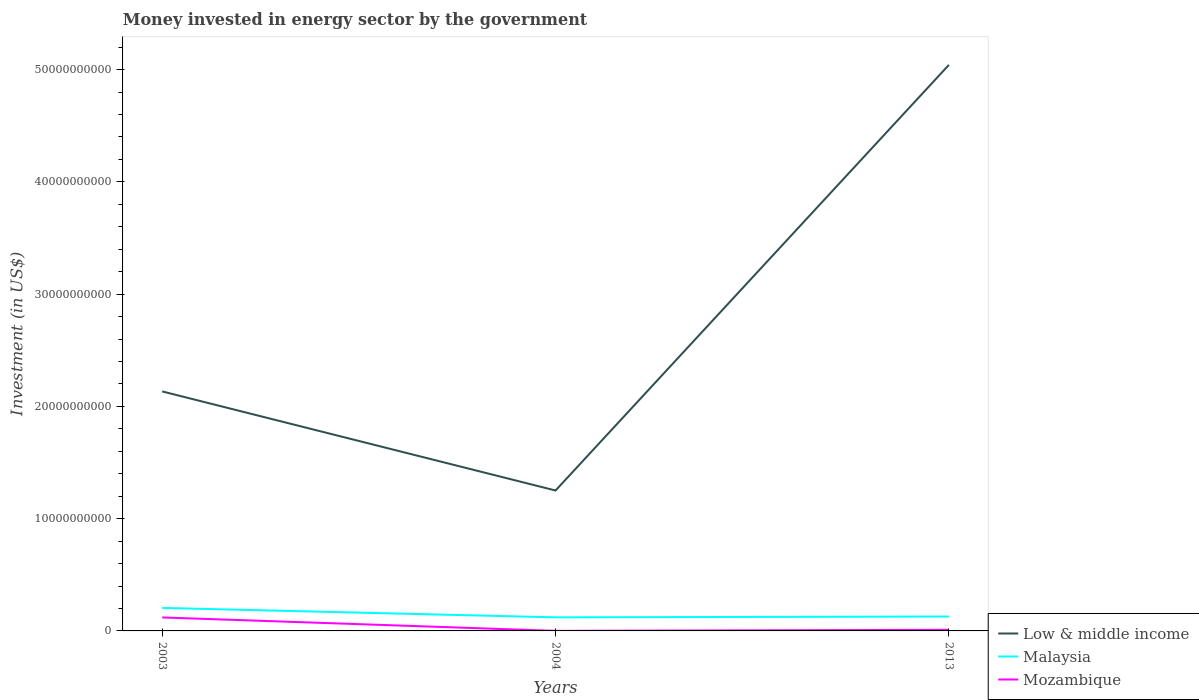How many different coloured lines are there?
Keep it short and to the point. 3. Does the line corresponding to Low & middle income intersect with the line corresponding to Malaysia?
Give a very brief answer. No. Across all years, what is the maximum money spent in energy sector in Malaysia?
Provide a short and direct response. 1.21e+09. In which year was the money spent in energy sector in Low & middle income maximum?
Offer a terse response. 2004. What is the total money spent in energy sector in Low & middle income in the graph?
Your answer should be very brief. -2.91e+1. What is the difference between the highest and the second highest money spent in energy sector in Mozambique?
Offer a terse response. 1.19e+09. How many years are there in the graph?
Keep it short and to the point. 3. Are the values on the major ticks of Y-axis written in scientific E-notation?
Make the answer very short. No. Does the graph contain any zero values?
Ensure brevity in your answer.  No. Does the graph contain grids?
Keep it short and to the point. No. How are the legend labels stacked?
Give a very brief answer. Vertical. What is the title of the graph?
Provide a short and direct response. Money invested in energy sector by the government. Does "Low income" appear as one of the legend labels in the graph?
Your response must be concise. No. What is the label or title of the X-axis?
Provide a short and direct response. Years. What is the label or title of the Y-axis?
Make the answer very short. Investment (in US$). What is the Investment (in US$) of Low & middle income in 2003?
Your answer should be compact. 2.13e+1. What is the Investment (in US$) in Malaysia in 2003?
Provide a succinct answer. 2.05e+09. What is the Investment (in US$) in Mozambique in 2003?
Ensure brevity in your answer.  1.20e+09. What is the Investment (in US$) of Low & middle income in 2004?
Give a very brief answer. 1.25e+1. What is the Investment (in US$) in Malaysia in 2004?
Provide a short and direct response. 1.21e+09. What is the Investment (in US$) in Mozambique in 2004?
Offer a very short reply. 5.80e+06. What is the Investment (in US$) in Low & middle income in 2013?
Your response must be concise. 5.04e+1. What is the Investment (in US$) of Malaysia in 2013?
Provide a short and direct response. 1.28e+09. What is the Investment (in US$) of Mozambique in 2013?
Provide a succinct answer. 9.87e+07. Across all years, what is the maximum Investment (in US$) in Low & middle income?
Provide a short and direct response. 5.04e+1. Across all years, what is the maximum Investment (in US$) in Malaysia?
Ensure brevity in your answer.  2.05e+09. Across all years, what is the maximum Investment (in US$) of Mozambique?
Give a very brief answer. 1.20e+09. Across all years, what is the minimum Investment (in US$) of Low & middle income?
Give a very brief answer. 1.25e+1. Across all years, what is the minimum Investment (in US$) of Malaysia?
Give a very brief answer. 1.21e+09. Across all years, what is the minimum Investment (in US$) in Mozambique?
Your response must be concise. 5.80e+06. What is the total Investment (in US$) of Low & middle income in the graph?
Offer a very short reply. 8.43e+1. What is the total Investment (in US$) of Malaysia in the graph?
Offer a very short reply. 4.54e+09. What is the total Investment (in US$) in Mozambique in the graph?
Ensure brevity in your answer.  1.30e+09. What is the difference between the Investment (in US$) in Low & middle income in 2003 and that in 2004?
Your response must be concise. 8.83e+09. What is the difference between the Investment (in US$) in Malaysia in 2003 and that in 2004?
Offer a very short reply. 8.40e+08. What is the difference between the Investment (in US$) in Mozambique in 2003 and that in 2004?
Give a very brief answer. 1.19e+09. What is the difference between the Investment (in US$) of Low & middle income in 2003 and that in 2013?
Your answer should be very brief. -2.91e+1. What is the difference between the Investment (in US$) in Malaysia in 2003 and that in 2013?
Provide a succinct answer. 7.67e+08. What is the difference between the Investment (in US$) in Mozambique in 2003 and that in 2013?
Provide a succinct answer. 1.10e+09. What is the difference between the Investment (in US$) of Low & middle income in 2004 and that in 2013?
Provide a succinct answer. -3.79e+1. What is the difference between the Investment (in US$) in Malaysia in 2004 and that in 2013?
Your response must be concise. -7.30e+07. What is the difference between the Investment (in US$) in Mozambique in 2004 and that in 2013?
Make the answer very short. -9.29e+07. What is the difference between the Investment (in US$) in Low & middle income in 2003 and the Investment (in US$) in Malaysia in 2004?
Provide a succinct answer. 2.01e+1. What is the difference between the Investment (in US$) of Low & middle income in 2003 and the Investment (in US$) of Mozambique in 2004?
Keep it short and to the point. 2.13e+1. What is the difference between the Investment (in US$) of Malaysia in 2003 and the Investment (in US$) of Mozambique in 2004?
Your answer should be very brief. 2.04e+09. What is the difference between the Investment (in US$) of Low & middle income in 2003 and the Investment (in US$) of Malaysia in 2013?
Provide a succinct answer. 2.01e+1. What is the difference between the Investment (in US$) in Low & middle income in 2003 and the Investment (in US$) in Mozambique in 2013?
Offer a terse response. 2.12e+1. What is the difference between the Investment (in US$) in Malaysia in 2003 and the Investment (in US$) in Mozambique in 2013?
Offer a terse response. 1.95e+09. What is the difference between the Investment (in US$) of Low & middle income in 2004 and the Investment (in US$) of Malaysia in 2013?
Your response must be concise. 1.12e+1. What is the difference between the Investment (in US$) in Low & middle income in 2004 and the Investment (in US$) in Mozambique in 2013?
Make the answer very short. 1.24e+1. What is the difference between the Investment (in US$) of Malaysia in 2004 and the Investment (in US$) of Mozambique in 2013?
Offer a terse response. 1.11e+09. What is the average Investment (in US$) in Low & middle income per year?
Offer a very short reply. 2.81e+1. What is the average Investment (in US$) in Malaysia per year?
Ensure brevity in your answer.  1.51e+09. What is the average Investment (in US$) in Mozambique per year?
Your answer should be compact. 4.35e+08. In the year 2003, what is the difference between the Investment (in US$) in Low & middle income and Investment (in US$) in Malaysia?
Your response must be concise. 1.93e+1. In the year 2003, what is the difference between the Investment (in US$) in Low & middle income and Investment (in US$) in Mozambique?
Provide a succinct answer. 2.01e+1. In the year 2003, what is the difference between the Investment (in US$) in Malaysia and Investment (in US$) in Mozambique?
Give a very brief answer. 8.50e+08. In the year 2004, what is the difference between the Investment (in US$) in Low & middle income and Investment (in US$) in Malaysia?
Make the answer very short. 1.13e+1. In the year 2004, what is the difference between the Investment (in US$) in Low & middle income and Investment (in US$) in Mozambique?
Keep it short and to the point. 1.25e+1. In the year 2004, what is the difference between the Investment (in US$) in Malaysia and Investment (in US$) in Mozambique?
Ensure brevity in your answer.  1.20e+09. In the year 2013, what is the difference between the Investment (in US$) in Low & middle income and Investment (in US$) in Malaysia?
Keep it short and to the point. 4.91e+1. In the year 2013, what is the difference between the Investment (in US$) of Low & middle income and Investment (in US$) of Mozambique?
Provide a short and direct response. 5.03e+1. In the year 2013, what is the difference between the Investment (in US$) in Malaysia and Investment (in US$) in Mozambique?
Provide a succinct answer. 1.18e+09. What is the ratio of the Investment (in US$) of Low & middle income in 2003 to that in 2004?
Provide a short and direct response. 1.71. What is the ratio of the Investment (in US$) in Malaysia in 2003 to that in 2004?
Provide a succinct answer. 1.69. What is the ratio of the Investment (in US$) of Mozambique in 2003 to that in 2004?
Your response must be concise. 206.9. What is the ratio of the Investment (in US$) in Low & middle income in 2003 to that in 2013?
Ensure brevity in your answer.  0.42. What is the ratio of the Investment (in US$) in Malaysia in 2003 to that in 2013?
Make the answer very short. 1.6. What is the ratio of the Investment (in US$) in Mozambique in 2003 to that in 2013?
Provide a short and direct response. 12.16. What is the ratio of the Investment (in US$) of Low & middle income in 2004 to that in 2013?
Offer a terse response. 0.25. What is the ratio of the Investment (in US$) of Malaysia in 2004 to that in 2013?
Make the answer very short. 0.94. What is the ratio of the Investment (in US$) in Mozambique in 2004 to that in 2013?
Provide a succinct answer. 0.06. What is the difference between the highest and the second highest Investment (in US$) in Low & middle income?
Your answer should be compact. 2.91e+1. What is the difference between the highest and the second highest Investment (in US$) in Malaysia?
Your answer should be compact. 7.67e+08. What is the difference between the highest and the second highest Investment (in US$) in Mozambique?
Keep it short and to the point. 1.10e+09. What is the difference between the highest and the lowest Investment (in US$) in Low & middle income?
Offer a terse response. 3.79e+1. What is the difference between the highest and the lowest Investment (in US$) in Malaysia?
Offer a very short reply. 8.40e+08. What is the difference between the highest and the lowest Investment (in US$) of Mozambique?
Make the answer very short. 1.19e+09. 